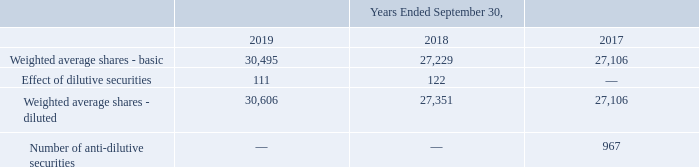Net Income (Loss) Per Share: Basic net income (loss) per share (EPS) is computed by dividing the net income (loss) attributable to Cubic for the period by the weighted average number of common shares outstanding during the period, including vested RSUs.
In periods with a net income from continuing operations attributable to Cubic, diluted EPS is computed by dividing the net income for the period by the weighted average number of common and common equivalent shares outstanding during the period. Common equivalent shares consist of dilutive RSUs. Dilutive RSUs are calculated based on the average share price for each fiscal period using the treasury stock method. For RSUs with performance-based vesting, no common equivalent shares are included in the computation of diluted EPS until the related performance criteria have been met. For RSUs with performance and market-based vesting, no common equivalent shares are included in the computation of diluted EPS until the performance criteria have been met, and once the criteria are met the dilutive restricted stock units are calculated using the treasury stock method, modified by the multiplier that is calculated at the end of the accounting period as if the vesting date was at the end of the accounting period. The multiplier on RSUs with performance and market-based vesting is further described in Note 16.
In periods with a net loss from continuing operations attributable to Cubic, common equivalent shares are not included in the computation of diluted EPS, because to do so would be anti-dilutive.
The weighted-average number of shares outstanding used to compute net income (loss) per common share were as follows (in thousands):
How is basic net income (loss) per share (EPS) computed? By dividing the net income (loss) attributable to cubic for the period by the weighted average number of common shares outstanding during the period, including vested rsus. How are dilutive RSUs calculated? Based on the average share price for each fiscal period using the treasury stock method. For which years was the weighted-average number of shares outstanding used to compute net income (loss) per common share recorded? 2019, 2018, 2017. Which year has the largest amount for the effect of dilutive securities? 122>111
Answer: 2018. What is the change in weighted average shares - basic in 2019 from 2018?
Answer scale should be: thousand. 30,495-27,229
Answer: 3266. What is the percentage change in weighted average shares - basic in 2019 from 2018?
Answer scale should be: percent. (30,495-27,229)/27,229
Answer: 11.99. 